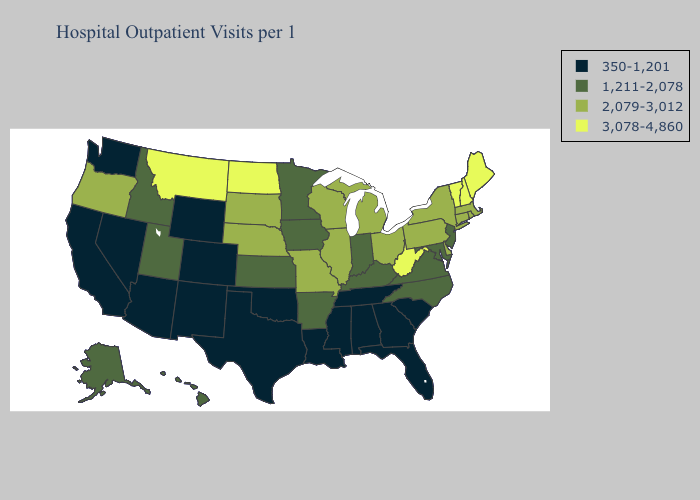Name the states that have a value in the range 2,079-3,012?
Give a very brief answer. Connecticut, Delaware, Illinois, Massachusetts, Michigan, Missouri, Nebraska, New York, Ohio, Oregon, Pennsylvania, Rhode Island, South Dakota, Wisconsin. What is the lowest value in the South?
Concise answer only. 350-1,201. What is the lowest value in the USA?
Give a very brief answer. 350-1,201. What is the highest value in states that border Arkansas?
Short answer required. 2,079-3,012. What is the highest value in the USA?
Short answer required. 3,078-4,860. What is the highest value in states that border North Carolina?
Concise answer only. 1,211-2,078. Name the states that have a value in the range 350-1,201?
Concise answer only. Alabama, Arizona, California, Colorado, Florida, Georgia, Louisiana, Mississippi, Nevada, New Mexico, Oklahoma, South Carolina, Tennessee, Texas, Washington, Wyoming. Does South Dakota have the highest value in the USA?
Answer briefly. No. What is the value of Nevada?
Give a very brief answer. 350-1,201. What is the highest value in the South ?
Keep it brief. 3,078-4,860. How many symbols are there in the legend?
Be succinct. 4. Which states have the lowest value in the USA?
Short answer required. Alabama, Arizona, California, Colorado, Florida, Georgia, Louisiana, Mississippi, Nevada, New Mexico, Oklahoma, South Carolina, Tennessee, Texas, Washington, Wyoming. Among the states that border New Mexico , does Utah have the lowest value?
Give a very brief answer. No. Does Massachusetts have the lowest value in the USA?
Concise answer only. No. Does South Dakota have the same value as Pennsylvania?
Short answer required. Yes. 